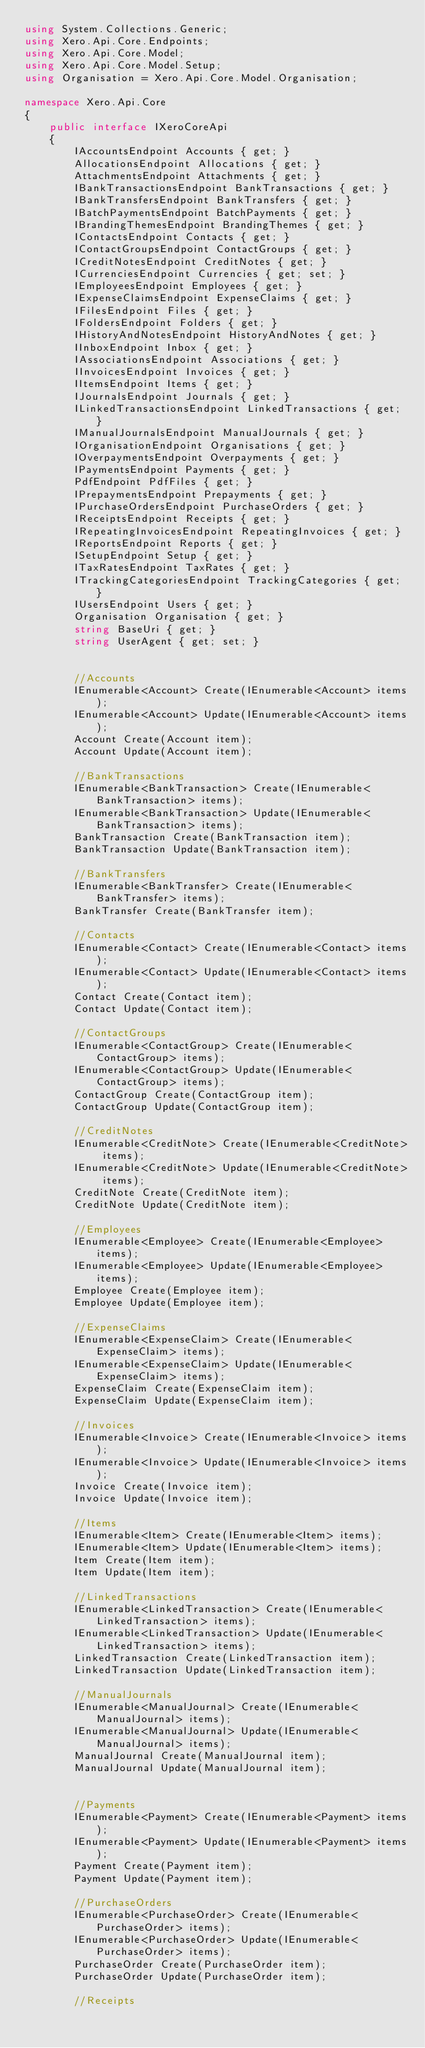Convert code to text. <code><loc_0><loc_0><loc_500><loc_500><_C#_>using System.Collections.Generic;
using Xero.Api.Core.Endpoints;
using Xero.Api.Core.Model;
using Xero.Api.Core.Model.Setup;
using Organisation = Xero.Api.Core.Model.Organisation;

namespace Xero.Api.Core
{
    public interface IXeroCoreApi
    {
        IAccountsEndpoint Accounts { get; }
        AllocationsEndpoint Allocations { get; }
        AttachmentsEndpoint Attachments { get; }
        IBankTransactionsEndpoint BankTransactions { get; }
        IBankTransfersEndpoint BankTransfers { get; }
        IBatchPaymentsEndpoint BatchPayments { get; }
        IBrandingThemesEndpoint BrandingThemes { get; }
        IContactsEndpoint Contacts { get; }
        IContactGroupsEndpoint ContactGroups { get; }
        ICreditNotesEndpoint CreditNotes { get; }
        ICurrenciesEndpoint Currencies { get; set; }
        IEmployeesEndpoint Employees { get; }
        IExpenseClaimsEndpoint ExpenseClaims { get; }
        IFilesEndpoint Files { get; }
        IFoldersEndpoint Folders { get; }
        IHistoryAndNotesEndpoint HistoryAndNotes { get; }
        IInboxEndpoint Inbox { get; }
        IAssociationsEndpoint Associations { get; }
        IInvoicesEndpoint Invoices { get; }
        IItemsEndpoint Items { get; }
        IJournalsEndpoint Journals { get; }
        ILinkedTransactionsEndpoint LinkedTransactions { get; }
        IManualJournalsEndpoint ManualJournals { get; }
        IOrganisationEndpoint Organisations { get; }
        IOverpaymentsEndpoint Overpayments { get; }
        IPaymentsEndpoint Payments { get; }
        PdfEndpoint PdfFiles { get; }
        IPrepaymentsEndpoint Prepayments { get; }
        IPurchaseOrdersEndpoint PurchaseOrders { get; }
        IReceiptsEndpoint Receipts { get; }
        IRepeatingInvoicesEndpoint RepeatingInvoices { get; }
        IReportsEndpoint Reports { get; }
        ISetupEndpoint Setup { get; }
        ITaxRatesEndpoint TaxRates { get; }
        ITrackingCategoriesEndpoint TrackingCategories { get; }
        IUsersEndpoint Users { get; }
        Organisation Organisation { get; }
        string BaseUri { get; }
        string UserAgent { get; set; }


        //Accounts
        IEnumerable<Account> Create(IEnumerable<Account> items);
        IEnumerable<Account> Update(IEnumerable<Account> items);
        Account Create(Account item);
        Account Update(Account item);

        //BankTransactions
        IEnumerable<BankTransaction> Create(IEnumerable<BankTransaction> items);
        IEnumerable<BankTransaction> Update(IEnumerable<BankTransaction> items);
        BankTransaction Create(BankTransaction item);
        BankTransaction Update(BankTransaction item);

        //BankTransfers
        IEnumerable<BankTransfer> Create(IEnumerable<BankTransfer> items);
        BankTransfer Create(BankTransfer item);

        //Contacts
        IEnumerable<Contact> Create(IEnumerable<Contact> items);
        IEnumerable<Contact> Update(IEnumerable<Contact> items);
        Contact Create(Contact item);
        Contact Update(Contact item);

        //ContactGroups
        IEnumerable<ContactGroup> Create(IEnumerable<ContactGroup> items);
        IEnumerable<ContactGroup> Update(IEnumerable<ContactGroup> items);
        ContactGroup Create(ContactGroup item);
        ContactGroup Update(ContactGroup item);

        //CreditNotes
        IEnumerable<CreditNote> Create(IEnumerable<CreditNote> items);
        IEnumerable<CreditNote> Update(IEnumerable<CreditNote> items);
        CreditNote Create(CreditNote item);
        CreditNote Update(CreditNote item);

        //Employees
        IEnumerable<Employee> Create(IEnumerable<Employee> items);
        IEnumerable<Employee> Update(IEnumerable<Employee> items);
        Employee Create(Employee item);
        Employee Update(Employee item);

        //ExpenseClaims
        IEnumerable<ExpenseClaim> Create(IEnumerable<ExpenseClaim> items);
        IEnumerable<ExpenseClaim> Update(IEnumerable<ExpenseClaim> items);
        ExpenseClaim Create(ExpenseClaim item);
        ExpenseClaim Update(ExpenseClaim item);

        //Invoices
        IEnumerable<Invoice> Create(IEnumerable<Invoice> items);
        IEnumerable<Invoice> Update(IEnumerable<Invoice> items);
        Invoice Create(Invoice item);
        Invoice Update(Invoice item);

        //Items
        IEnumerable<Item> Create(IEnumerable<Item> items);
        IEnumerable<Item> Update(IEnumerable<Item> items);
        Item Create(Item item);
        Item Update(Item item);

        //LinkedTransactions
        IEnumerable<LinkedTransaction> Create(IEnumerable<LinkedTransaction> items);
        IEnumerable<LinkedTransaction> Update(IEnumerable<LinkedTransaction> items);
        LinkedTransaction Create(LinkedTransaction item);
        LinkedTransaction Update(LinkedTransaction item);

        //ManualJournals
        IEnumerable<ManualJournal> Create(IEnumerable<ManualJournal> items);
        IEnumerable<ManualJournal> Update(IEnumerable<ManualJournal> items);
        ManualJournal Create(ManualJournal item);
        ManualJournal Update(ManualJournal item);

        
        //Payments
        IEnumerable<Payment> Create(IEnumerable<Payment> items);
        IEnumerable<Payment> Update(IEnumerable<Payment> items);
        Payment Create(Payment item);
        Payment Update(Payment item);
        
        //PurchaseOrders
        IEnumerable<PurchaseOrder> Create(IEnumerable<PurchaseOrder> items);
        IEnumerable<PurchaseOrder> Update(IEnumerable<PurchaseOrder> items);
        PurchaseOrder Create(PurchaseOrder item);
        PurchaseOrder Update(PurchaseOrder item);

        //Receipts</code> 